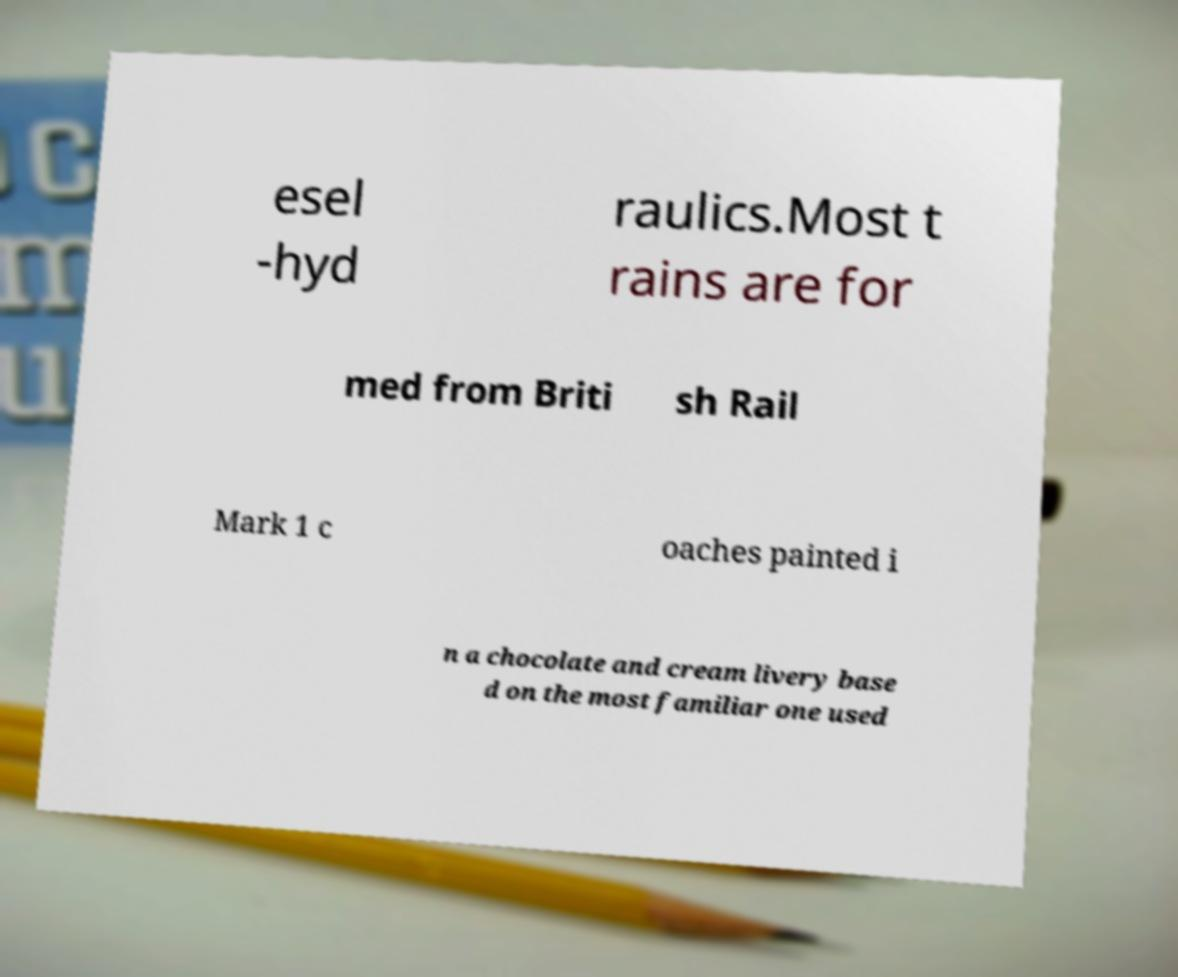Can you read and provide the text displayed in the image?This photo seems to have some interesting text. Can you extract and type it out for me? esel -hyd raulics.Most t rains are for med from Briti sh Rail Mark 1 c oaches painted i n a chocolate and cream livery base d on the most familiar one used 